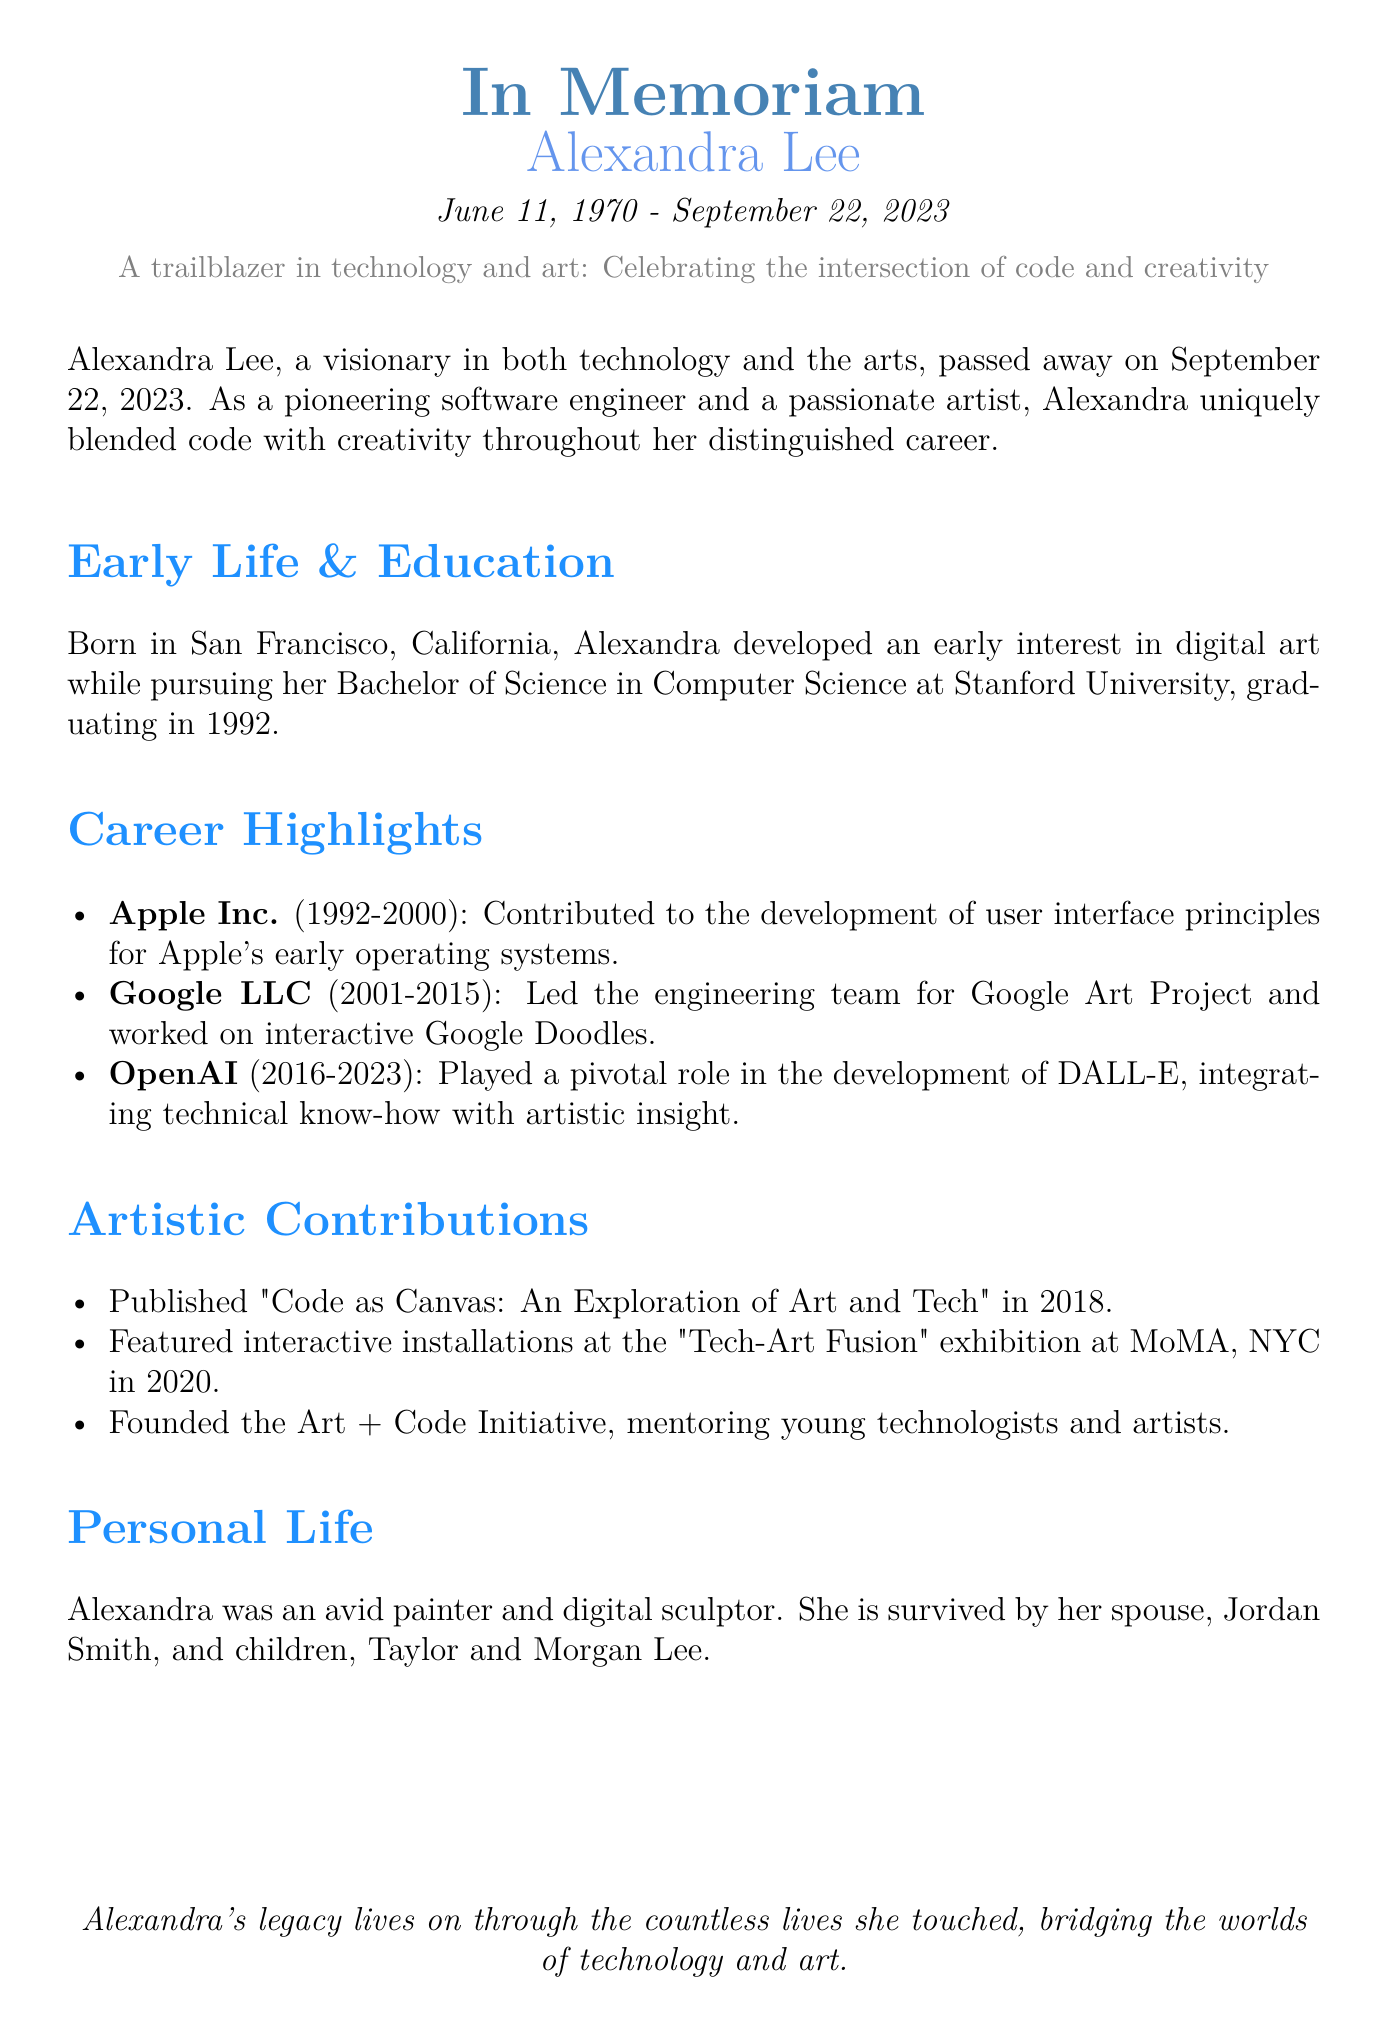What date did Alexandra Lee pass away? The date of Alexandra Lee's passing is mentioned in the document.
Answer: September 22, 2023 Where did Alexandra Lee earn her degree? The document states her educational background, including the institution where she graduated.
Answer: Stanford University What was one of her roles at Google LLC? The document lists her contributions while at Google, including leading a specific engineering team.
Answer: Led the engineering team for Google Art Project In which year was the book "Code as Canvas" published? The document specifies the publication year of her book.
Answer: 2018 What initiative did Alexandra Lee found? The document highlights her contribution to mentoring young technologists and artists through a specific initiative.
Answer: Art + Code Initiative How many children does Alexandra Lee have? The document mentions her family details, specifically the number of children she had.
Answer: Two What medium was Alexandra Lee known for in her personal life? Her artistic preferences are detailed in the document, indicating her interests and skills.
Answer: Painter and digital sculptor During which exhibition did she feature her interactive installations? The document provides information about her artistic contributions, including an exhibition name.
Answer: Tech-Art Fusion What innovative project was Alexandra a part of at OpenAI? The document discusses one of her significant roles during her time at OpenAI, referring to a popular project.
Answer: DALL-E 